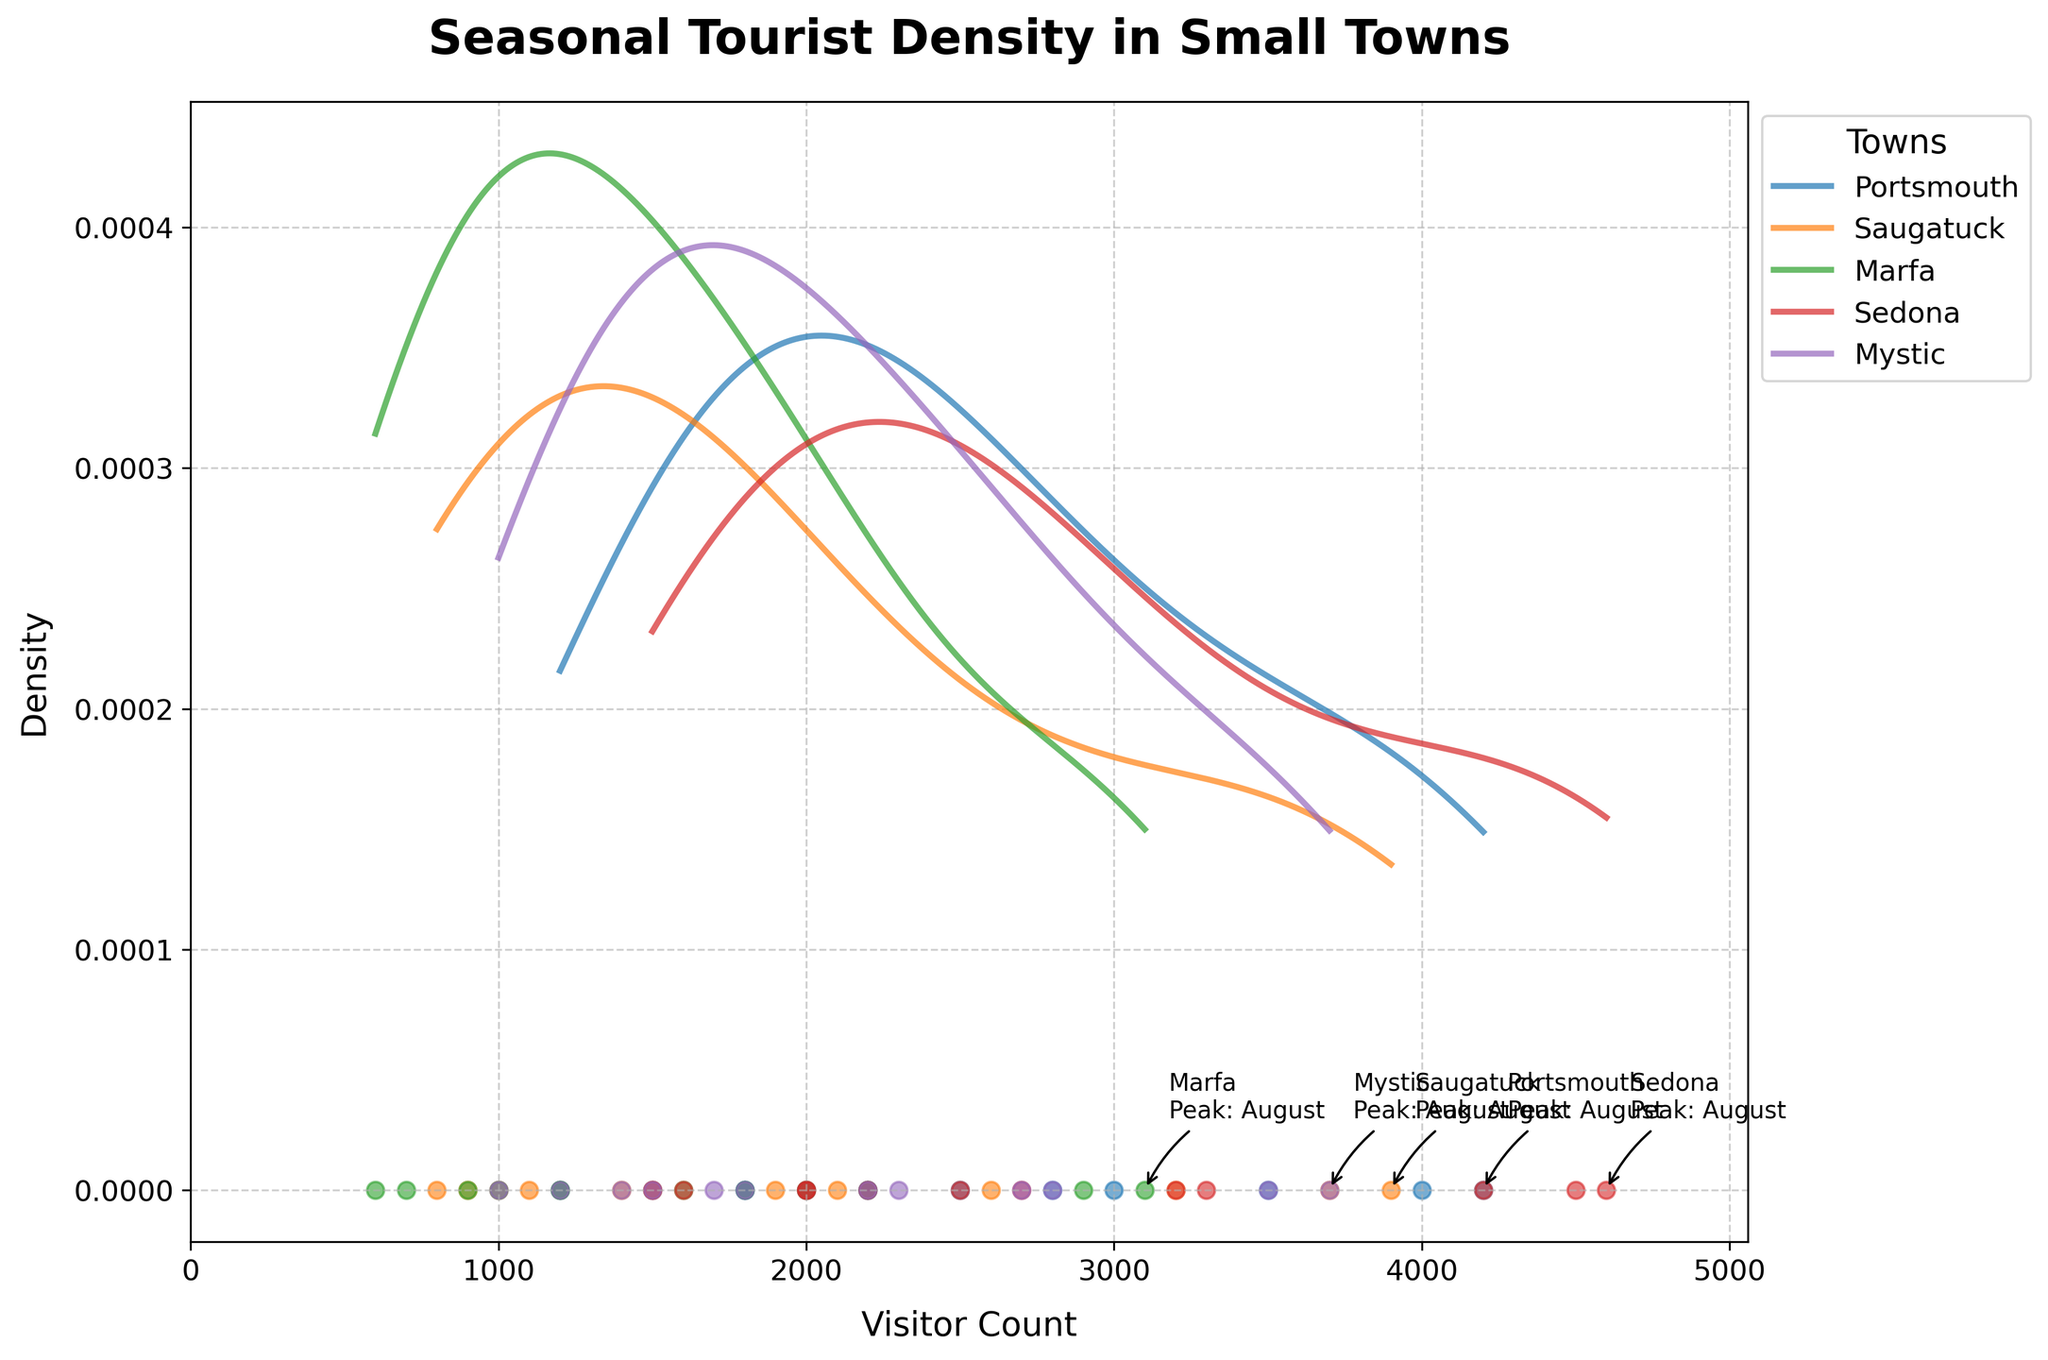What is the title of the figure? The title is usually placed at the top of the figure. In this case, the title is specifically defined with `ax.set_title()`.
Answer: Seasonal Tourist Density in Small Towns What does the X-axis represent? The X-axis is labeled with `Visitor Count`, which can be concluded from the code setting `ax.set_xlabel()`.
Answer: Visitor Count Which town has the highest peak visitor count? From the annotations in the figure, the highest peak can be identified directly. Both the visitor count and corresponding town are labeled.
Answer: Sedona During which month does Sedona reach its peak visitor count? Sedona's peak month is indicated in the figure near the highest density point for Sedona, as set by an annotation.
Answer: August Compare the highest visitor counts of Portsmouth and Saugatuck. Which town has more visitors at its peak? The annotations for each town show their peak visitor counts, allowing for direct comparison. `Portsmouth: 4200` and `Saugatuck: 3900`.
Answer: Portsmouth How does Marfa's peak visitor count compare to the lowest visitor count in Mystic? Marfa's peak visitor count is annotated and can be compared to the scatter points for Mystic, of which the lowest is `1000`.
Answer: Higher Which town has the lowest peak visitor count? Check the annotations for peak months and visitor counts. The lowest among them is Marfa with `3100`.
Answer: Marfa What is the visitor count range with the highest density for Sedona? The dense areas on the curve for Sedona around the peak can be identified visually; the highest densities concentrate around `4500` to `4600`.
Answer: 4500-4600 What month does Portsmouth's visitor count start to decrease after its peak? By following the scatter plot points after the peak, Portsmouth shows a decline starting from `August`.
Answer: September Compare the density curves of Mystics and Saugatuck. Which town shows a broader spread in visitor counts? From the width of the density curves, a broader spread indicates a wider range of visitor counts. Saugatuck's density curve appears broader in this visual comparison.
Answer: Saugatuck 